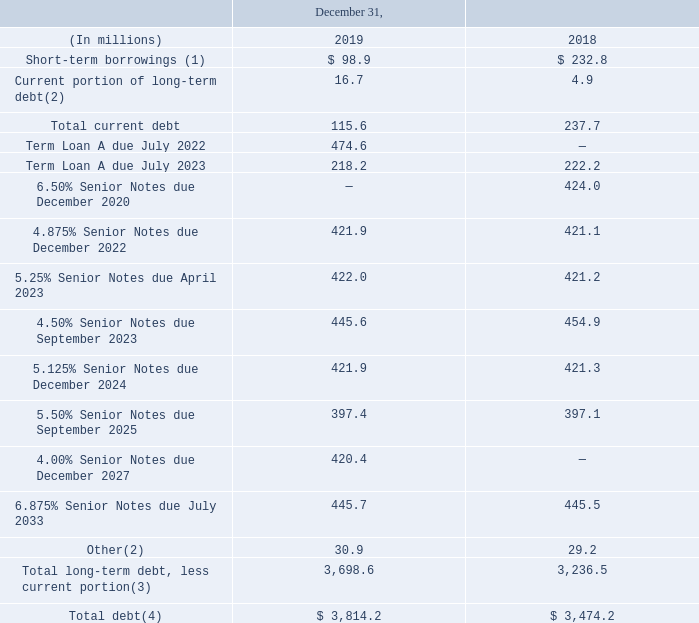Note 14 Debt and Credit Facilities
Our total debt outstanding consisted of the amounts set forth on the following table:
(1) Short-term borrowings of $98.9 million at December 31, 2019 were comprised of $89.0 million under our revolving credit facility and $9.9 million of short-term borrowings from various lines of credit. Short-term borrowings of $232.8 million at December 31, 2018 were comprised of $140.0 million under our revolving credit facility, $83.9 million under our European securitization program and $8.9 million of short-term borrowings from various lines of credit.
(2) The Current portion of long-term debt includes finance lease liabilities of $10.4 million as of December 31, 2019. The Other debt balance includes $28.7 million for long-term liabilities associated with our finance leases as of December 31, 2019. See Note 4, "Leases," of the Notes to Condensed Consolidated Financial Statements for additional information on finance and operating lease liabilities.
(3) Amounts are net of unamortized discounts and issuance costs of $24.6 million and $24.3 million as of December 31, 2019 and 2018, respectively.
(4) As of December 31, 2019, our weighted average interest rate on our short-term borrowings outstanding was 5.0% and on our long-term debt outstanding was 4.8%. As of December 31, 2018, our weighted average interest rate on our short-term borrowings outstanding was 2.8% and on our long-term debt outstanding was 5.4%.
What were Short-term borrowings of $98.9 million at December 31, 2019 comprised of? $89.0 million under our revolving credit facility and $9.9 million of short-term borrowings from various lines of credit. What years are included for total debt outstanding? 2019, 2018. What unit is used in the table? Millions. What is the total Term Loan A due as of December 31, 2019?
Answer scale should be: million. 474.6+218.2
Answer: 692.8. What is the percentage of Total long-term debt, less current portion to Total debt as of December 31, 2019?
Answer scale should be: percent. 3,698.6/3,814.2
Answer: 96.97. What is the percentage increase between the Total Debt as of 31 December, 2018 to as of 31 December, 2019? 
Answer scale should be: percent. (3,814.2-3,474.2)/3,474.2
Answer: 9.79. 